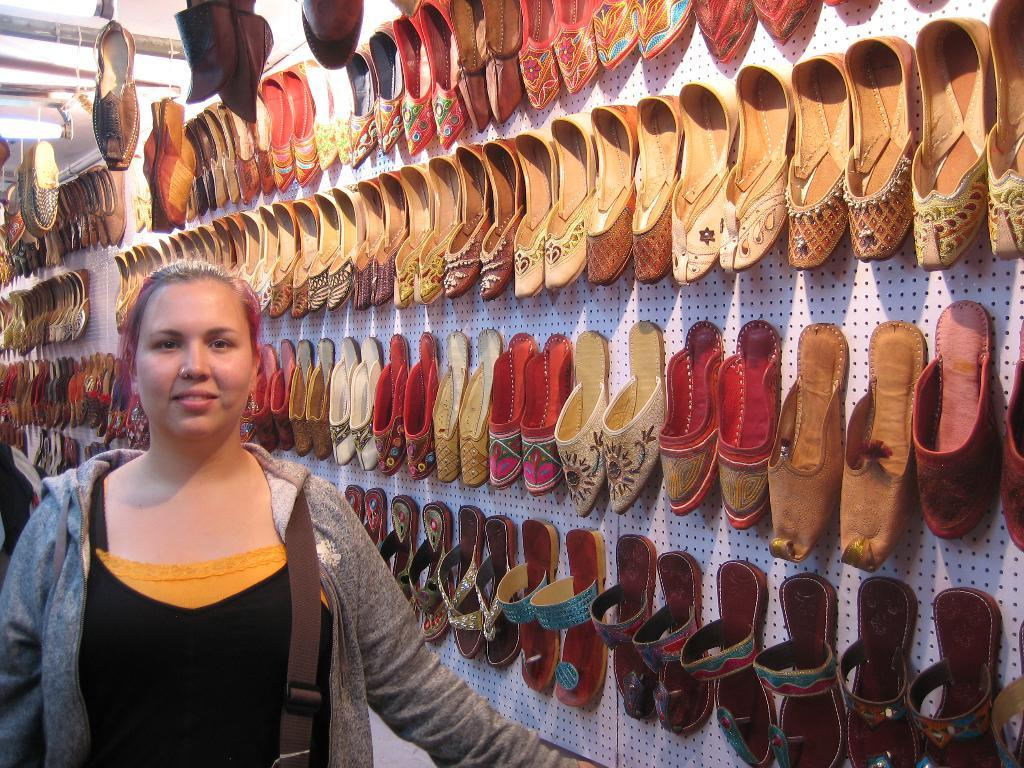Who is present in the image? There is a lady in the image. What is the lady wearing? The lady is wearing a bag. What can be seen on a board in the background of the image? There are shoes and chappals on a board in the background of the image. Can you tell me what type of goldfish is swimming in the lady's bag in the image? There is no goldfish present in the image; the lady is wearing a bag, but it is not specified what is inside the bag. 